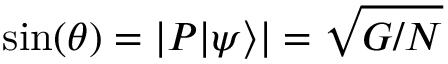<formula> <loc_0><loc_0><loc_500><loc_500>\sin ( \theta ) = | P | \psi \rangle | = { \sqrt { G / N } }</formula> 